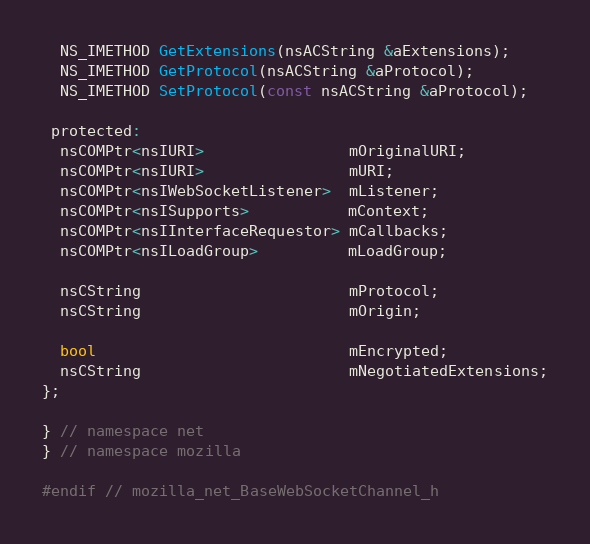Convert code to text. <code><loc_0><loc_0><loc_500><loc_500><_C_>  NS_IMETHOD GetExtensions(nsACString &aExtensions);
  NS_IMETHOD GetProtocol(nsACString &aProtocol);
  NS_IMETHOD SetProtocol(const nsACString &aProtocol);

 protected:
  nsCOMPtr<nsIURI>                mOriginalURI;
  nsCOMPtr<nsIURI>                mURI;
  nsCOMPtr<nsIWebSocketListener>  mListener;
  nsCOMPtr<nsISupports>           mContext;
  nsCOMPtr<nsIInterfaceRequestor> mCallbacks;
  nsCOMPtr<nsILoadGroup>          mLoadGroup;

  nsCString                       mProtocol;
  nsCString                       mOrigin;

  bool                            mEncrypted;
  nsCString                       mNegotiatedExtensions;
};

} // namespace net
} // namespace mozilla

#endif // mozilla_net_BaseWebSocketChannel_h
</code> 